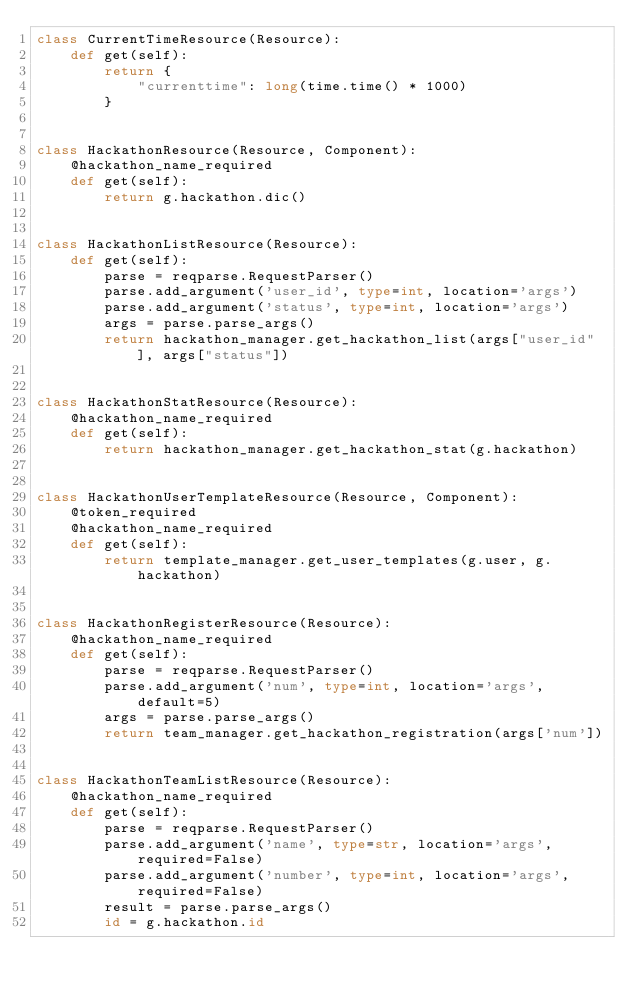Convert code to text. <code><loc_0><loc_0><loc_500><loc_500><_Python_>class CurrentTimeResource(Resource):
    def get(self):
        return {
            "currenttime": long(time.time() * 1000)
        }


class HackathonResource(Resource, Component):
    @hackathon_name_required
    def get(self):
        return g.hackathon.dic()


class HackathonListResource(Resource):
    def get(self):
        parse = reqparse.RequestParser()
        parse.add_argument('user_id', type=int, location='args')
        parse.add_argument('status', type=int, location='args')
        args = parse.parse_args()
        return hackathon_manager.get_hackathon_list(args["user_id"], args["status"])


class HackathonStatResource(Resource):
    @hackathon_name_required
    def get(self):
        return hackathon_manager.get_hackathon_stat(g.hackathon)


class HackathonUserTemplateResource(Resource, Component):
    @token_required
    @hackathon_name_required
    def get(self):
        return template_manager.get_user_templates(g.user, g.hackathon)


class HackathonRegisterResource(Resource):
    @hackathon_name_required
    def get(self):
        parse = reqparse.RequestParser()
        parse.add_argument('num', type=int, location='args', default=5)
        args = parse.parse_args()
        return team_manager.get_hackathon_registration(args['num'])


class HackathonTeamListResource(Resource):
    @hackathon_name_required
    def get(self):
        parse = reqparse.RequestParser()
        parse.add_argument('name', type=str, location='args', required=False)
        parse.add_argument('number', type=int, location='args', required=False)
        result = parse.parse_args()
        id = g.hackathon.id</code> 